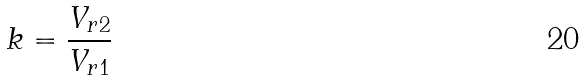Convert formula to latex. <formula><loc_0><loc_0><loc_500><loc_500>k = \frac { V _ { r 2 } } { V _ { r 1 } }</formula> 